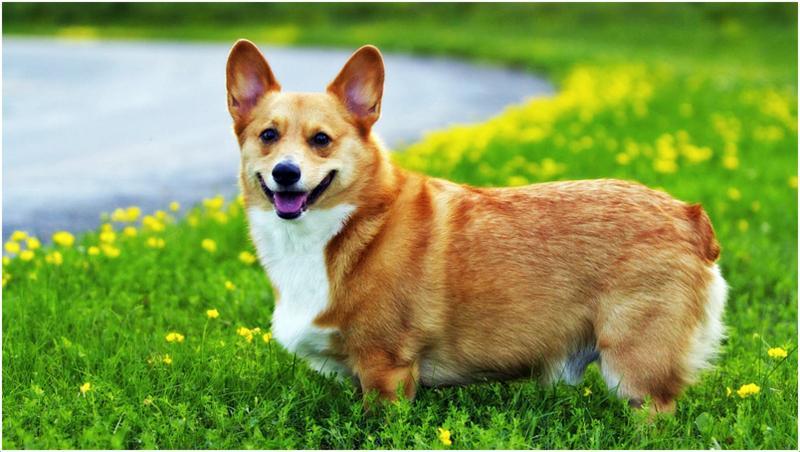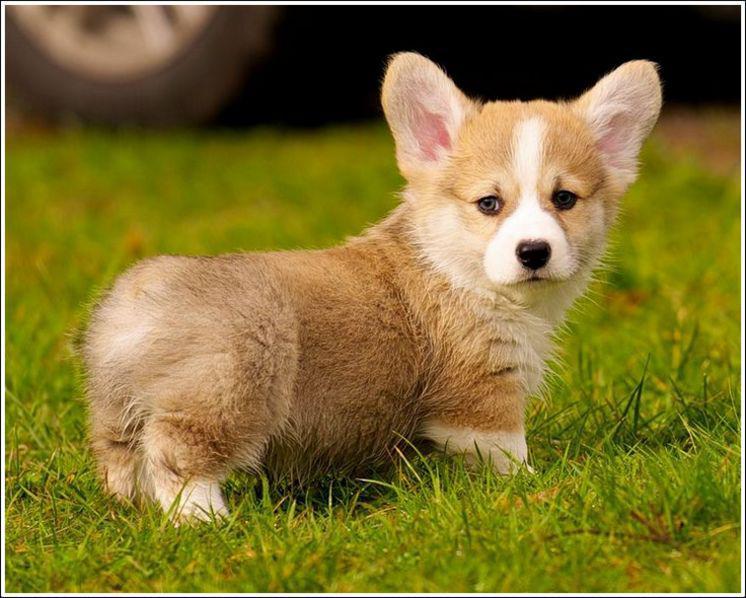The first image is the image on the left, the second image is the image on the right. For the images displayed, is the sentence "The dogs in the images are standing with bodies turned in opposite directions." factually correct? Answer yes or no. Yes. 